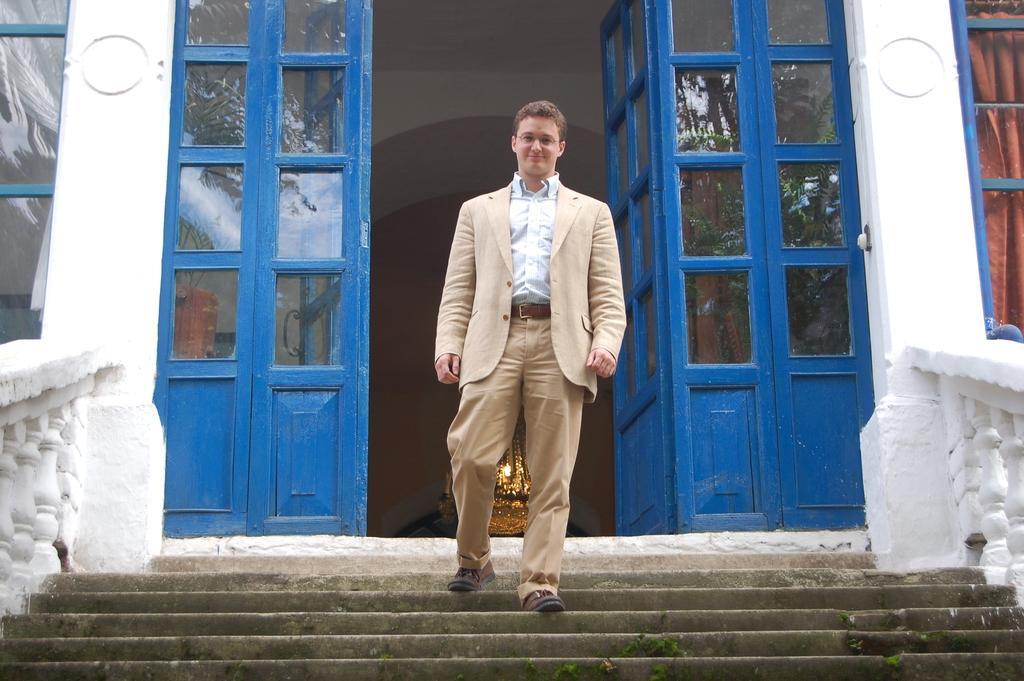Please provide a concise description of this image. There is a man on the stairs in the foreground area of the image, there are doors and windows in the background. 